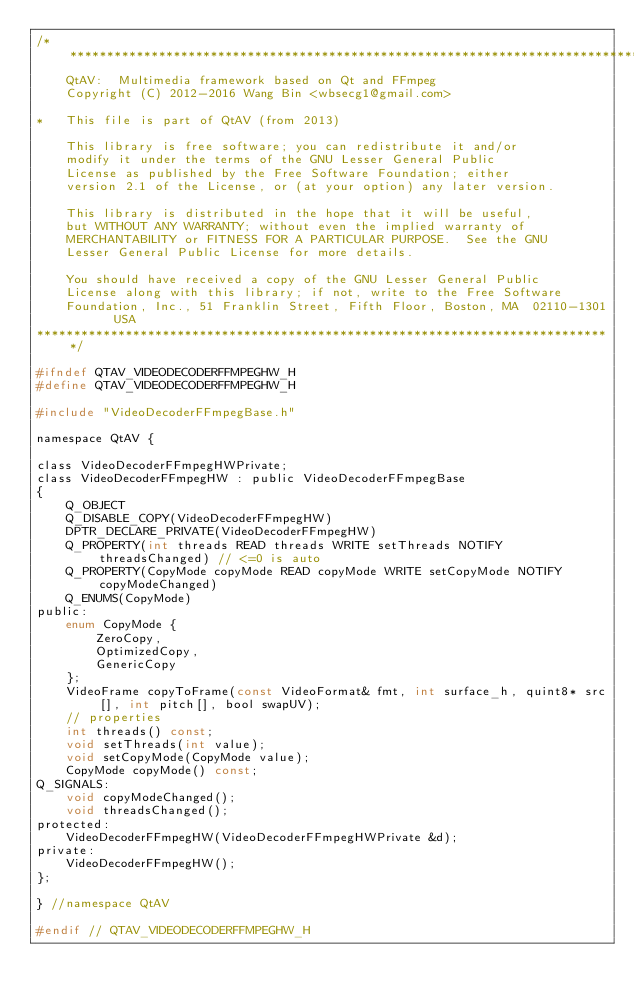Convert code to text. <code><loc_0><loc_0><loc_500><loc_500><_C_>/******************************************************************************
    QtAV:  Multimedia framework based on Qt and FFmpeg
    Copyright (C) 2012-2016 Wang Bin <wbsecg1@gmail.com>

*   This file is part of QtAV (from 2013)

    This library is free software; you can redistribute it and/or
    modify it under the terms of the GNU Lesser General Public
    License as published by the Free Software Foundation; either
    version 2.1 of the License, or (at your option) any later version.

    This library is distributed in the hope that it will be useful,
    but WITHOUT ANY WARRANTY; without even the implied warranty of
    MERCHANTABILITY or FITNESS FOR A PARTICULAR PURPOSE.  See the GNU
    Lesser General Public License for more details.

    You should have received a copy of the GNU Lesser General Public
    License along with this library; if not, write to the Free Software
    Foundation, Inc., 51 Franklin Street, Fifth Floor, Boston, MA  02110-1301  USA
******************************************************************************/

#ifndef QTAV_VIDEODECODERFFMPEGHW_H
#define QTAV_VIDEODECODERFFMPEGHW_H

#include "VideoDecoderFFmpegBase.h"

namespace QtAV {

class VideoDecoderFFmpegHWPrivate;
class VideoDecoderFFmpegHW : public VideoDecoderFFmpegBase
{
    Q_OBJECT
    Q_DISABLE_COPY(VideoDecoderFFmpegHW)
    DPTR_DECLARE_PRIVATE(VideoDecoderFFmpegHW)
    Q_PROPERTY(int threads READ threads WRITE setThreads NOTIFY threadsChanged) // <=0 is auto
    Q_PROPERTY(CopyMode copyMode READ copyMode WRITE setCopyMode NOTIFY copyModeChanged)
    Q_ENUMS(CopyMode)
public:
    enum CopyMode {
        ZeroCopy,
        OptimizedCopy,
        GenericCopy
    };
    VideoFrame copyToFrame(const VideoFormat& fmt, int surface_h, quint8* src[], int pitch[], bool swapUV);
    // properties
    int threads() const;
    void setThreads(int value);
    void setCopyMode(CopyMode value);
    CopyMode copyMode() const;
Q_SIGNALS:
    void copyModeChanged();
    void threadsChanged();
protected:
    VideoDecoderFFmpegHW(VideoDecoderFFmpegHWPrivate &d);
private:
    VideoDecoderFFmpegHW();
};

} //namespace QtAV

#endif // QTAV_VIDEODECODERFFMPEGHW_H
</code> 